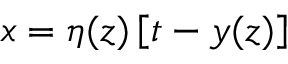Convert formula to latex. <formula><loc_0><loc_0><loc_500><loc_500>x = \eta ( z ) \left [ t - y ( z ) \right ]</formula> 